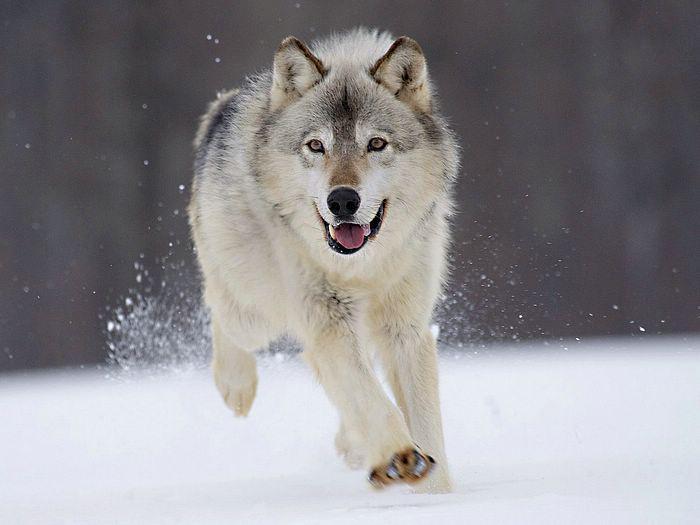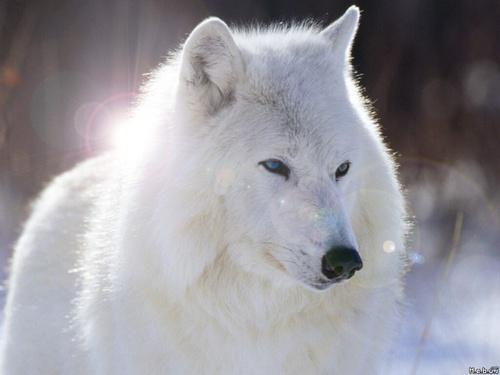The first image is the image on the left, the second image is the image on the right. For the images shown, is this caption "The animal in the image on the right has a white coat." true? Answer yes or no. Yes. 